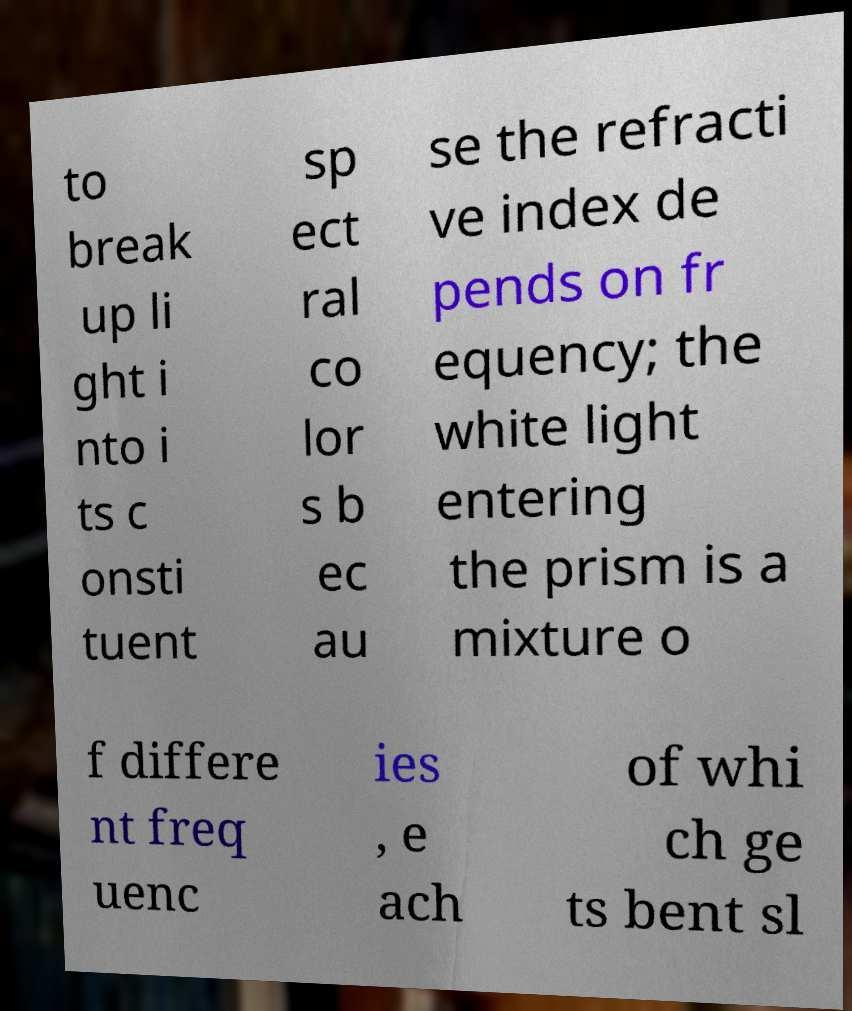For documentation purposes, I need the text within this image transcribed. Could you provide that? to break up li ght i nto i ts c onsti tuent sp ect ral co lor s b ec au se the refracti ve index de pends on fr equency; the white light entering the prism is a mixture o f differe nt freq uenc ies , e ach of whi ch ge ts bent sl 